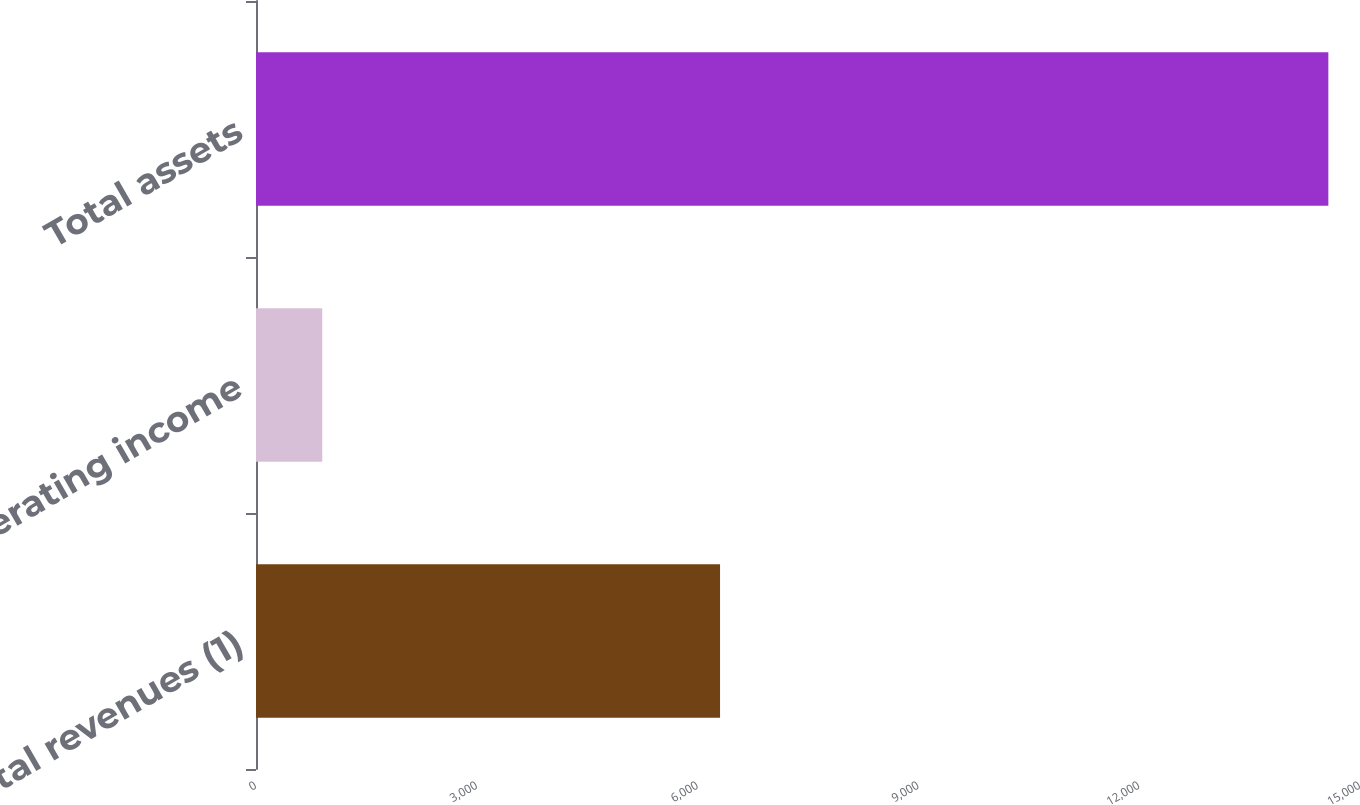Convert chart to OTSL. <chart><loc_0><loc_0><loc_500><loc_500><bar_chart><fcel>Total revenues (1)<fcel>Operating income<fcel>Total assets<nl><fcel>6305<fcel>900<fcel>14570<nl></chart> 